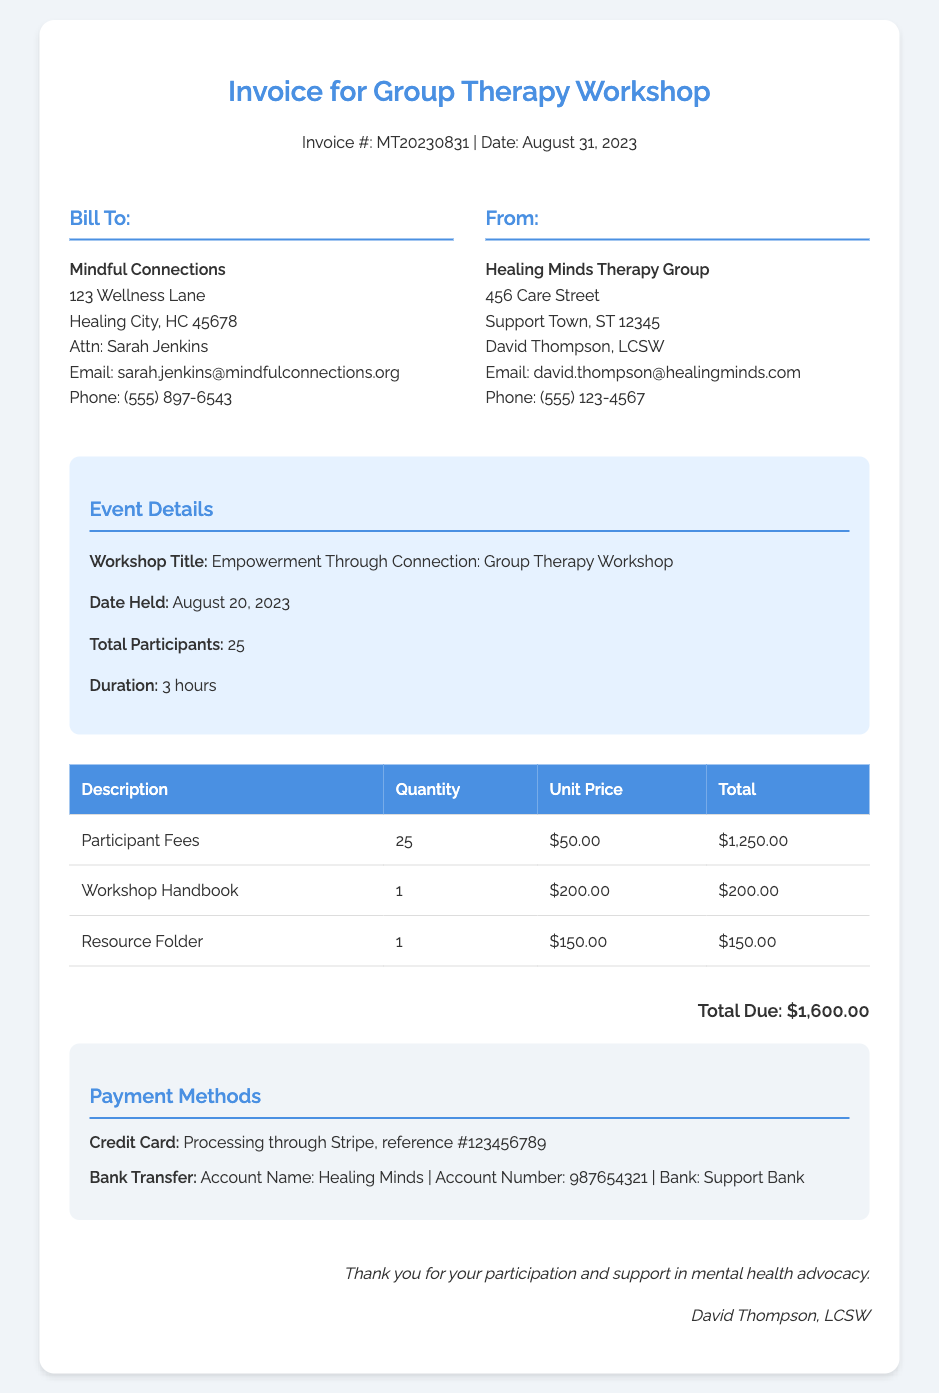What is the invoice number? The invoice number is provided at the top of the document, denoted as "Invoice #:".
Answer: MT20230831 What is the date of the invoice? The date is mentioned under the invoice number in the header section.
Answer: August 31, 2023 Who is the invoice billed to? The "Bill To:" section identifies the recipient of the invoice.
Answer: Mindful Connections What is the total due amount? The total due amount is clearly indicated at the bottom of the invoice.
Answer: $1,600.00 What is the unit price for participant fees? The unit price is listed in the itemized section of the invoice for participant fees.
Answer: $50.00 How many participants attended the workshop? The number of participants is mentioned in the event details section.
Answer: 25 What materials were provided during the workshop? The document lists specific materials provided, which are identified in the itemized section.
Answer: Workshop Handbook, Resource Folder What payment method was used for processing? The payment methods section details the methods accepted, specifically mentioning one utilized for credit card transactions.
Answer: Credit Card Who is the signatory of the invoice? The signature section at the bottom identifies the individual who signed the invoice.
Answer: David Thompson, LCSW 